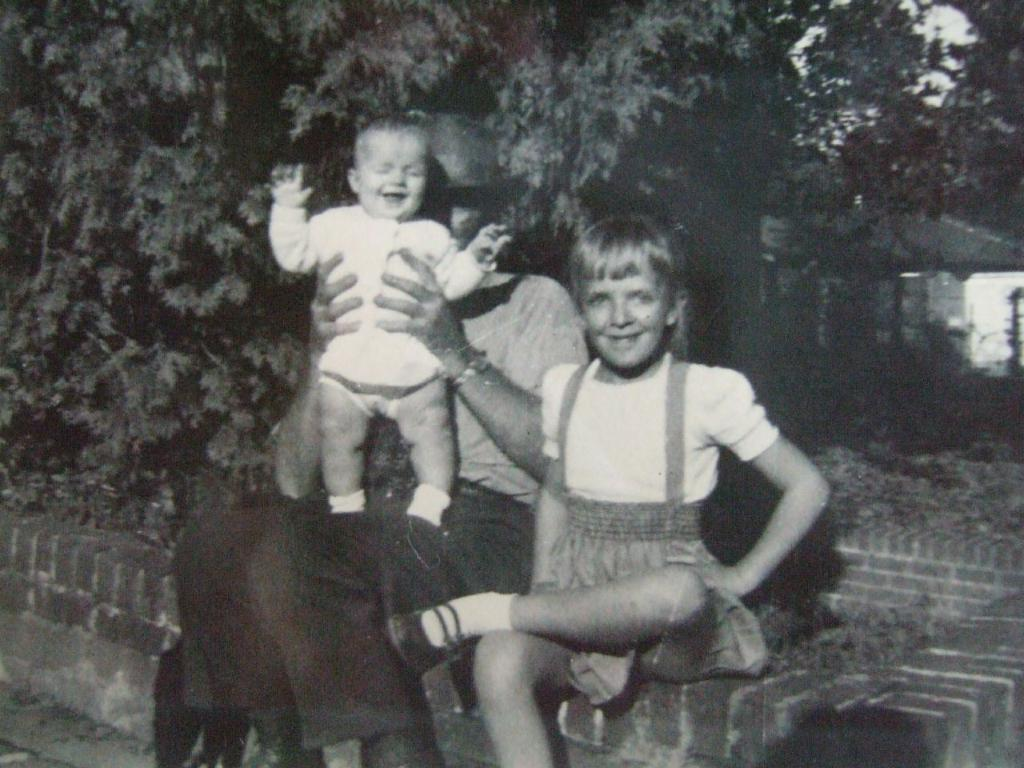What is the color scheme of the image? The image is black and white. What is the man in the image doing? The man is holding a baby in the image. Who else is present in the image besides the man and the baby? There is a girl sitting beside the man on a wall in the image. What can be seen in the background of the image? There are trees visible in the background of the image. How many eyes does the sock have in the image? There is no sock present in the image, so it is not possible to determine the number of eyes it might have. 